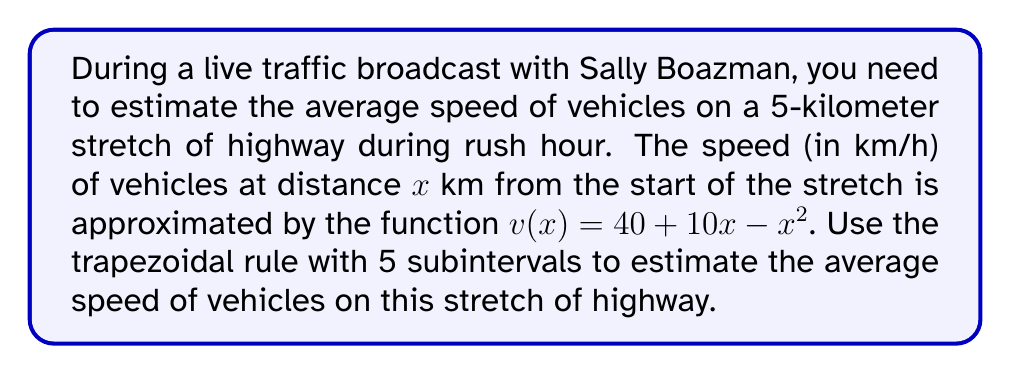Could you help me with this problem? To estimate the average speed using numerical integration:

1) The average speed is given by:
   $$\text{Average Speed} = \frac{1}{b-a}\int_{a}^{b} v(x) dx$$
   where $a=0$ and $b=5$ in this case.

2) We'll use the trapezoidal rule with 5 subintervals:
   $$\int_{a}^{b} f(x) dx \approx \frac{h}{2}[f(x_0) + 2f(x_1) + 2f(x_2) + 2f(x_3) + 2f(x_4) + f(x_5)]$$
   where $h = \frac{b-a}{n} = \frac{5-0}{5} = 1$

3) Calculate function values:
   $v(0) = 40 + 10(0) - 0^2 = 40$
   $v(1) = 40 + 10(1) - 1^2 = 49$
   $v(2) = 40 + 10(2) - 2^2 = 56$
   $v(3) = 40 + 10(3) - 3^2 = 61$
   $v(4) = 40 + 10(4) - 4^2 = 64$
   $v(5) = 40 + 10(5) - 5^2 = 65$

4) Apply the trapezoidal rule:
   $$\int_{0}^{5} v(x) dx \approx \frac{1}{2}[40 + 2(49) + 2(56) + 2(61) + 2(64) + 65]$$
   $$= \frac{1}{2}[40 + 98 + 112 + 122 + 128 + 65] = \frac{565}{2} = 282.5$$

5) Calculate the average speed:
   $$\text{Average Speed} = \frac{1}{5-0}\int_{0}^{5} v(x) dx \approx \frac{282.5}{5} = 56.5$$

Therefore, the estimated average speed is 56.5 km/h.
Answer: 56.5 km/h 